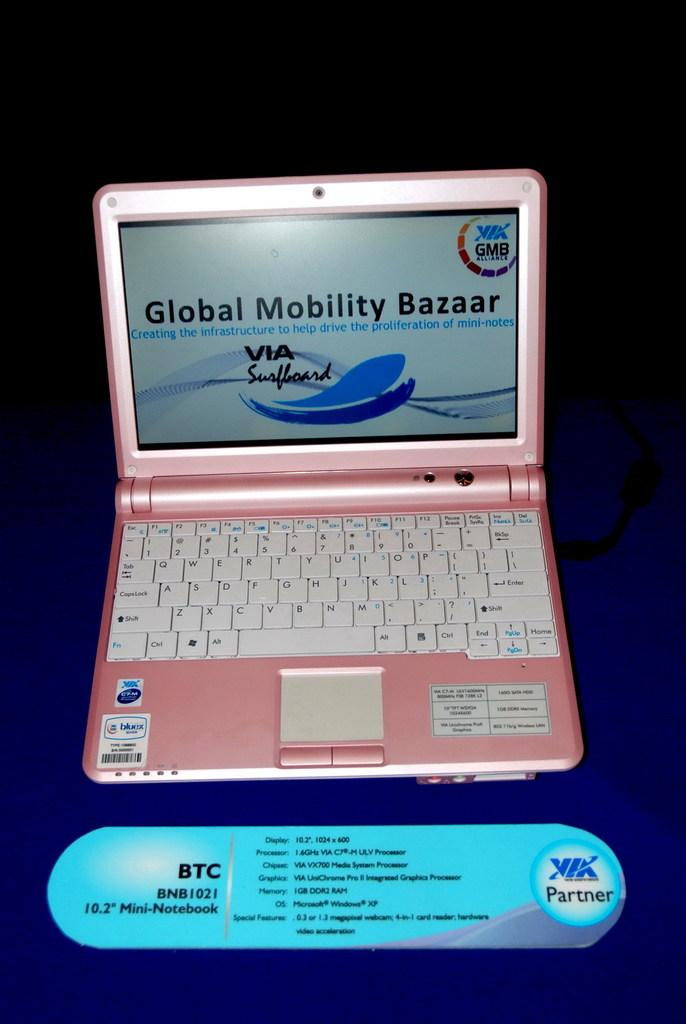Provide a one-sentence caption for the provided image. A pink laptop that has a page loaded on the screen that says Global Mobility Bazaar. 